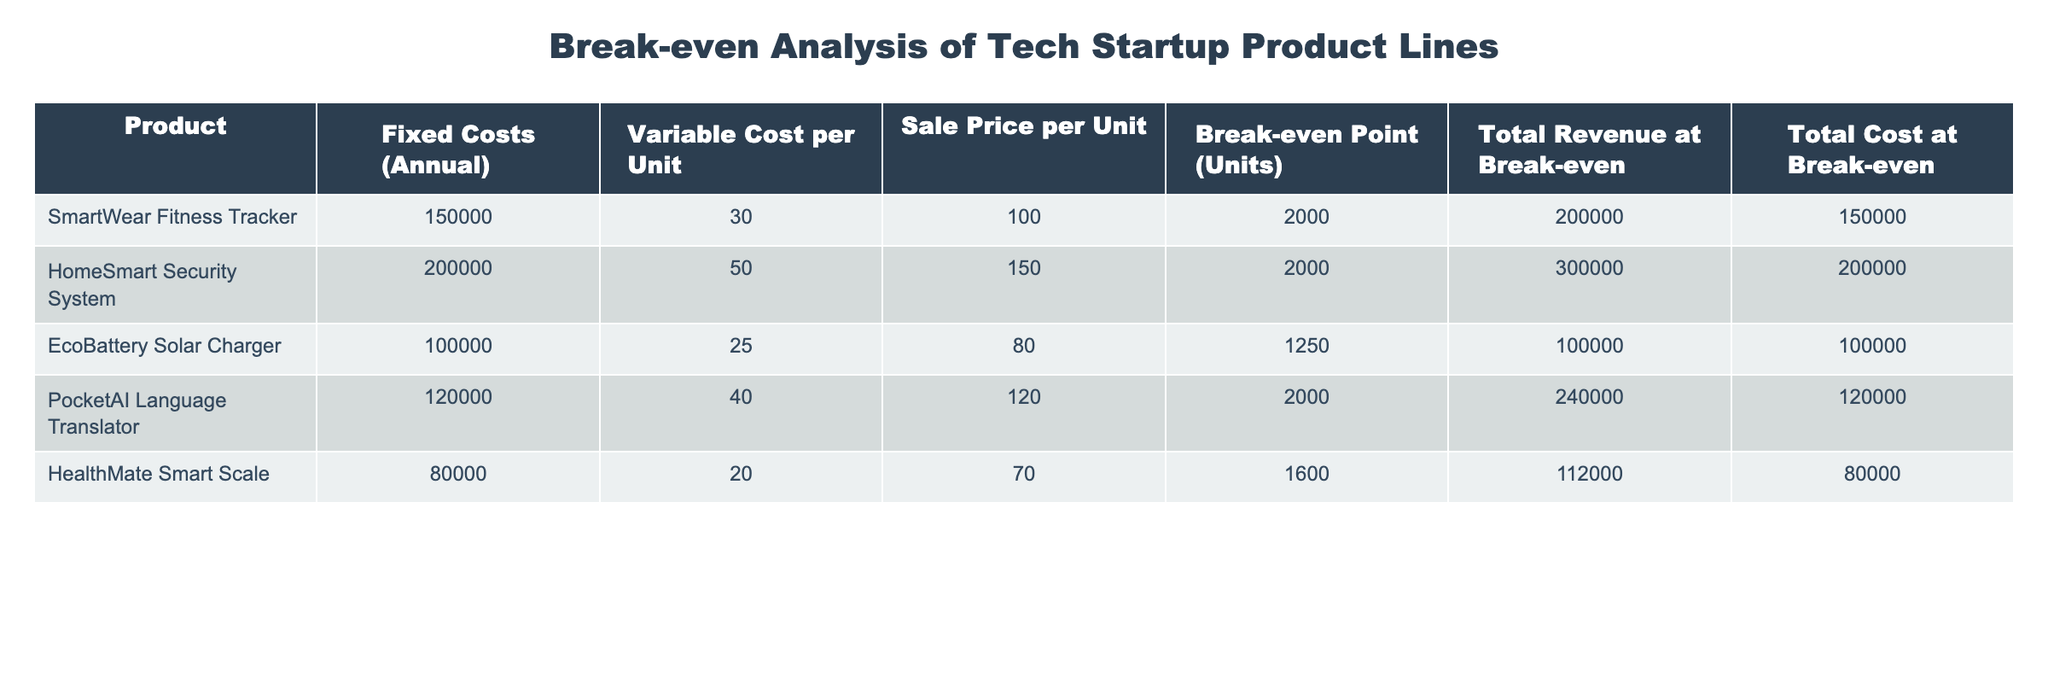What is the break-even point in units for the SmartWear Fitness Tracker? The break-even point for the SmartWear Fitness Tracker is directly listed in the table under "Break-even Point (Units)," which shows a value of 2000 units.
Answer: 2000 What is the total revenue at break-even for the EcoBattery Solar Charger? The total revenue at break-even for the EcoBattery Solar Charger can be found in the "Total Revenue at Break-even" column for that product, which is 100000.
Answer: 100000 Which product has the highest fixed costs? By comparing the "Fixed Costs (Annual)" column for each product, the HomeSmart Security System has the highest fixed costs at 200000.
Answer: HomeSmart Security System What is the average variable cost per unit across all products? The variable costs per unit are 30, 50, 25, 40, and 20, adding these gives 165. Dividing this sum by 5 (the number of products), the average variable cost is 165/5 = 33.
Answer: 33 Is the total cost at break-even for the PocketAI Language Translator higher than the total revenue at break-even for the HealthMate Smart Scale? The total cost at break-even for PocketAI Language Translator is 120000, and for HealthMate Smart Scale, it is 80000. Since 120000 is greater than 80000, the statement is true.
Answer: Yes How much higher is the total revenue at break-even for the HomeSmart Security System compared to the EcoBattery Solar Charger? The total revenue at break-even for the HomeSmart Security System is 300000 and for the EcoBattery Solar Charger, it is 100000. Subtracting these values, 300000 - 100000 gives a difference of 200000.
Answer: 200000 What is the total cost at break-even for the product with the lowest fixed costs? The product with the lowest fixed costs is the HealthMate Smart Scale at 80000, and its total cost at break-even is also listed as 80000.
Answer: 80000 How many units need to be sold for the product with the highest break-even point? The highest break-even point in the table is 2000 units, which applies to both the SmartWear Fitness Tracker and PocketAI Language Translator.
Answer: 2000 Are the fixed costs for the EcoBattery Solar Charger lower than those for the SmartWear Fitness Tracker? The fixed costs for EcoBattery Solar Charger are 100000, while for SmartWear Fitness Tracker, they are 150000. Since 100000 is less than 150000, the statement is true.
Answer: Yes 